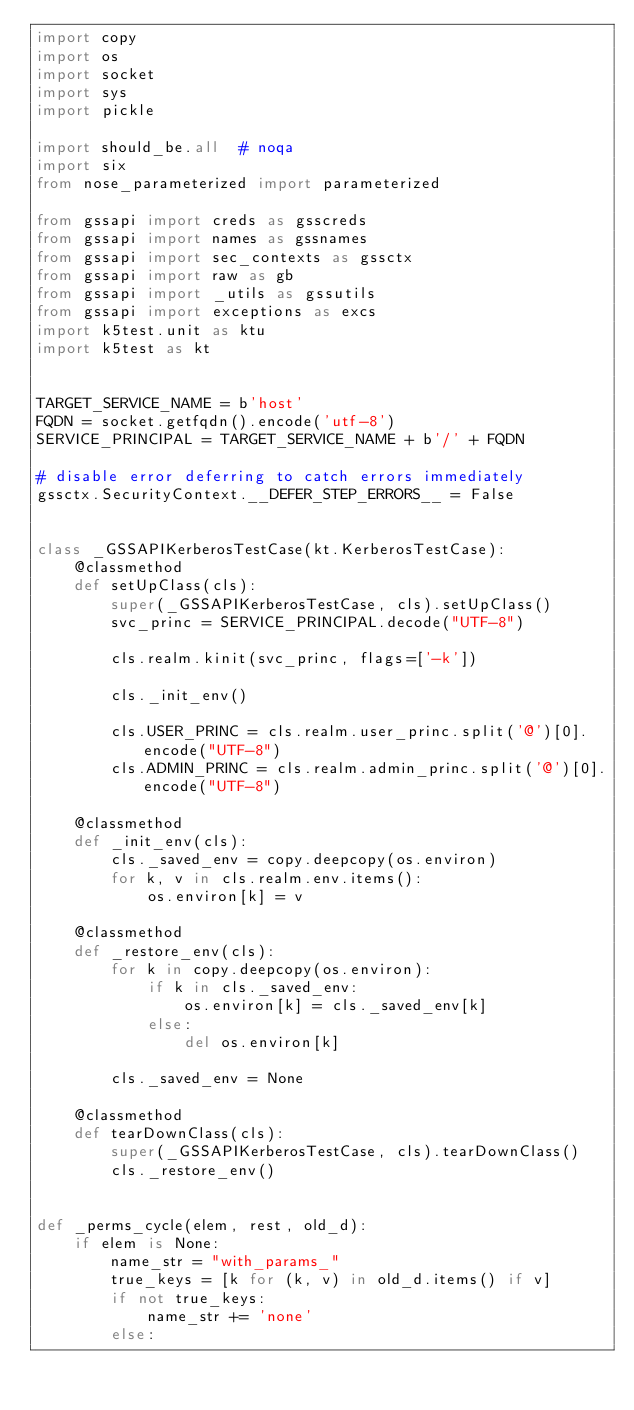Convert code to text. <code><loc_0><loc_0><loc_500><loc_500><_Python_>import copy
import os
import socket
import sys
import pickle

import should_be.all  # noqa
import six
from nose_parameterized import parameterized

from gssapi import creds as gsscreds
from gssapi import names as gssnames
from gssapi import sec_contexts as gssctx
from gssapi import raw as gb
from gssapi import _utils as gssutils
from gssapi import exceptions as excs
import k5test.unit as ktu
import k5test as kt


TARGET_SERVICE_NAME = b'host'
FQDN = socket.getfqdn().encode('utf-8')
SERVICE_PRINCIPAL = TARGET_SERVICE_NAME + b'/' + FQDN

# disable error deferring to catch errors immediately
gssctx.SecurityContext.__DEFER_STEP_ERRORS__ = False


class _GSSAPIKerberosTestCase(kt.KerberosTestCase):
    @classmethod
    def setUpClass(cls):
        super(_GSSAPIKerberosTestCase, cls).setUpClass()
        svc_princ = SERVICE_PRINCIPAL.decode("UTF-8")

        cls.realm.kinit(svc_princ, flags=['-k'])

        cls._init_env()

        cls.USER_PRINC = cls.realm.user_princ.split('@')[0].encode("UTF-8")
        cls.ADMIN_PRINC = cls.realm.admin_princ.split('@')[0].encode("UTF-8")

    @classmethod
    def _init_env(cls):
        cls._saved_env = copy.deepcopy(os.environ)
        for k, v in cls.realm.env.items():
            os.environ[k] = v

    @classmethod
    def _restore_env(cls):
        for k in copy.deepcopy(os.environ):
            if k in cls._saved_env:
                os.environ[k] = cls._saved_env[k]
            else:
                del os.environ[k]

        cls._saved_env = None

    @classmethod
    def tearDownClass(cls):
        super(_GSSAPIKerberosTestCase, cls).tearDownClass()
        cls._restore_env()


def _perms_cycle(elem, rest, old_d):
    if elem is None:
        name_str = "with_params_"
        true_keys = [k for (k, v) in old_d.items() if v]
        if not true_keys:
            name_str += 'none'
        else:</code> 